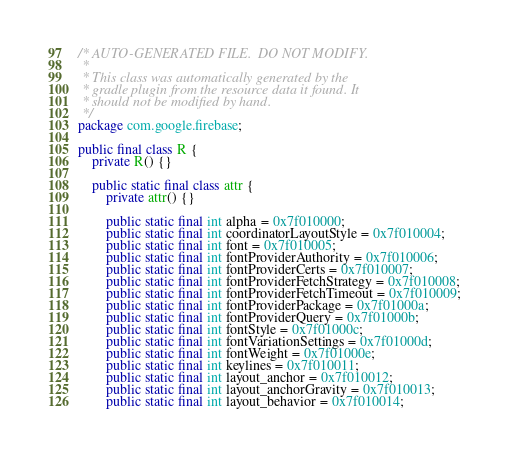Convert code to text. <code><loc_0><loc_0><loc_500><loc_500><_Java_>/* AUTO-GENERATED FILE.  DO NOT MODIFY.
 *
 * This class was automatically generated by the
 * gradle plugin from the resource data it found. It
 * should not be modified by hand.
 */
package com.google.firebase;

public final class R {
    private R() {}

    public static final class attr {
        private attr() {}

        public static final int alpha = 0x7f010000;
        public static final int coordinatorLayoutStyle = 0x7f010004;
        public static final int font = 0x7f010005;
        public static final int fontProviderAuthority = 0x7f010006;
        public static final int fontProviderCerts = 0x7f010007;
        public static final int fontProviderFetchStrategy = 0x7f010008;
        public static final int fontProviderFetchTimeout = 0x7f010009;
        public static final int fontProviderPackage = 0x7f01000a;
        public static final int fontProviderQuery = 0x7f01000b;
        public static final int fontStyle = 0x7f01000c;
        public static final int fontVariationSettings = 0x7f01000d;
        public static final int fontWeight = 0x7f01000e;
        public static final int keylines = 0x7f010011;
        public static final int layout_anchor = 0x7f010012;
        public static final int layout_anchorGravity = 0x7f010013;
        public static final int layout_behavior = 0x7f010014;</code> 